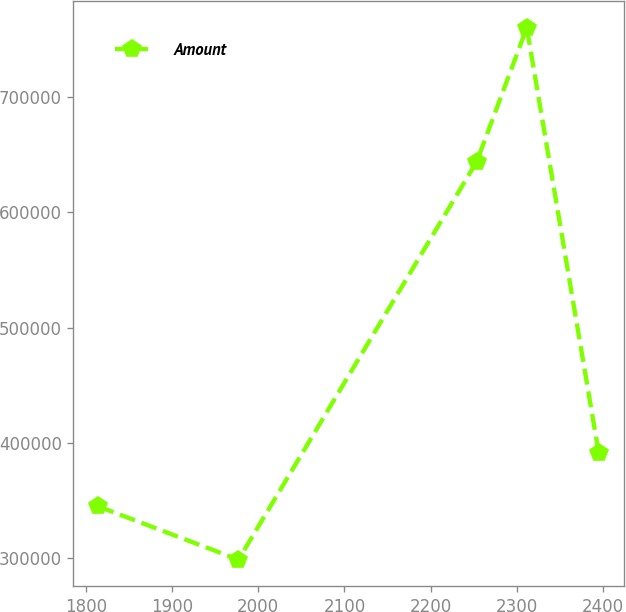Convert chart. <chart><loc_0><loc_0><loc_500><loc_500><line_chart><ecel><fcel>Amount<nl><fcel>1814.51<fcel>344785<nl><fcel>1977<fcel>298638<nl><fcel>2253.51<fcel>644035<nl><fcel>2311.57<fcel>760113<nl><fcel>2395.08<fcel>390933<nl></chart> 